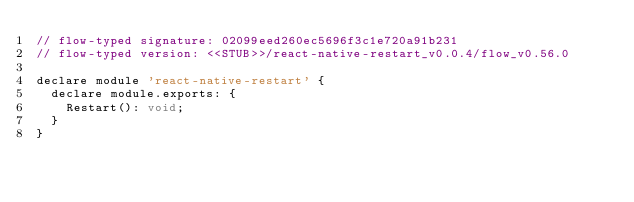<code> <loc_0><loc_0><loc_500><loc_500><_JavaScript_>// flow-typed signature: 02099eed260ec5696f3c1e720a91b231
// flow-typed version: <<STUB>>/react-native-restart_v0.0.4/flow_v0.56.0

declare module 'react-native-restart' {
  declare module.exports: {
    Restart(): void;
  }
}
</code> 